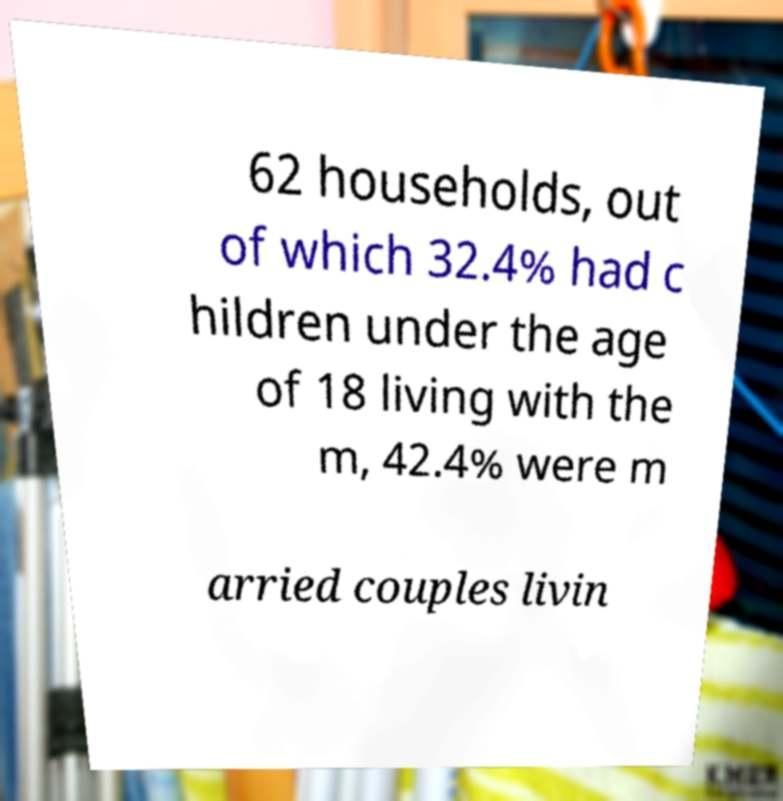Could you extract and type out the text from this image? 62 households, out of which 32.4% had c hildren under the age of 18 living with the m, 42.4% were m arried couples livin 